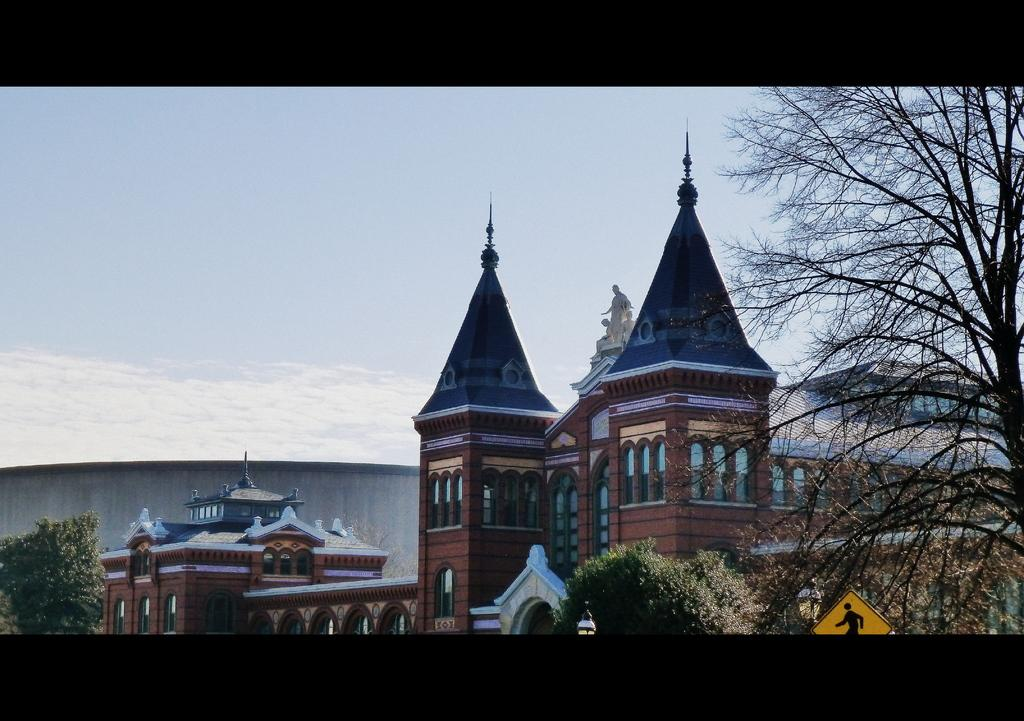What can be seen in the foreground of the picture? In the foreground of the picture, there are trees, a sign board, a street light, and a building. Can you describe the tree on the left side of the picture? Yes, there is a tree on the left side of the picture. What is the condition of the sky in the picture? The sky is sunny in the picture. What type of instrument is being played by the snake in the picture? There are no snakes or instruments present in the image. How many steps are visible in the picture? There are no steps visible in the picture. 